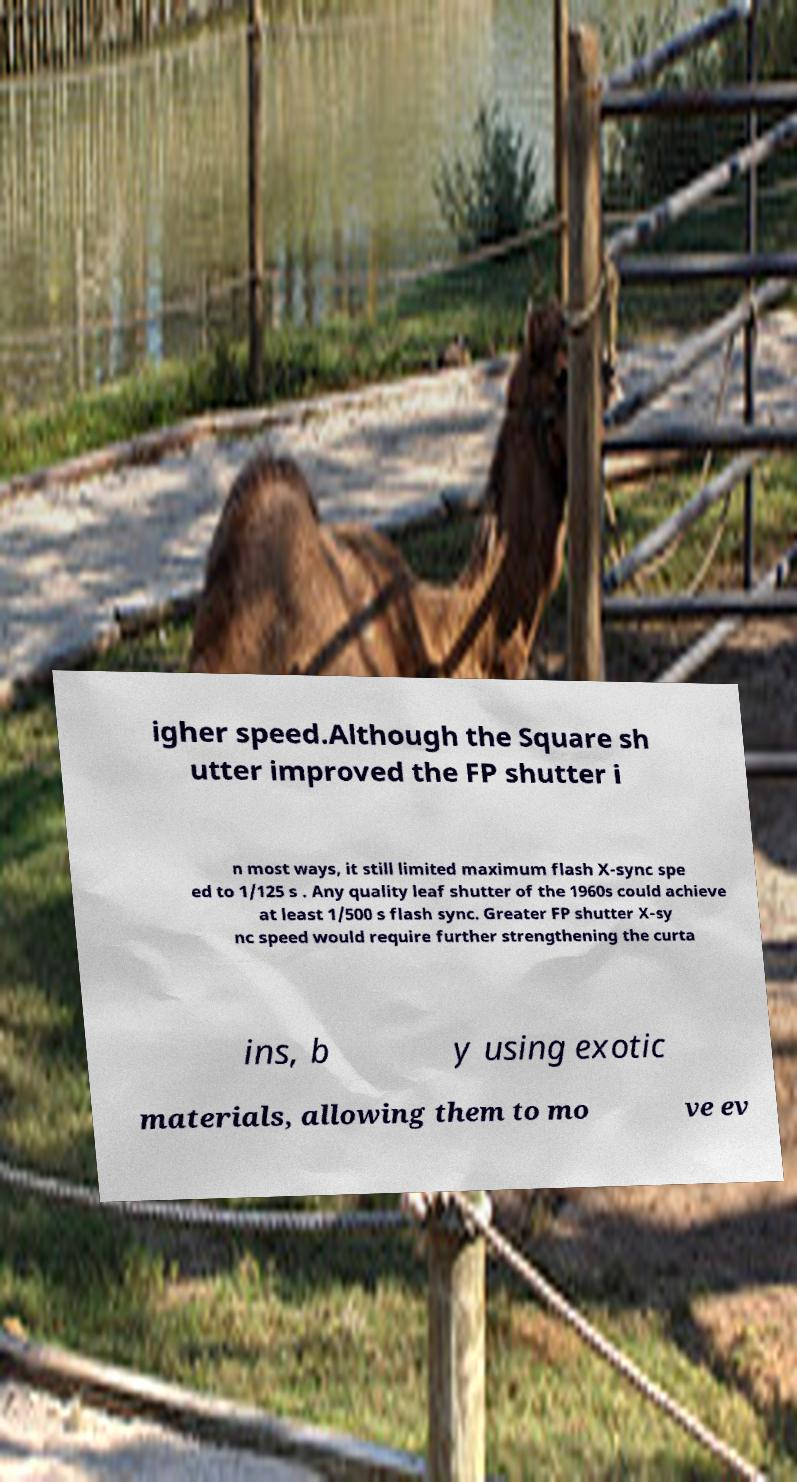For documentation purposes, I need the text within this image transcribed. Could you provide that? igher speed.Although the Square sh utter improved the FP shutter i n most ways, it still limited maximum flash X-sync spe ed to 1/125 s . Any quality leaf shutter of the 1960s could achieve at least 1/500 s flash sync. Greater FP shutter X-sy nc speed would require further strengthening the curta ins, b y using exotic materials, allowing them to mo ve ev 